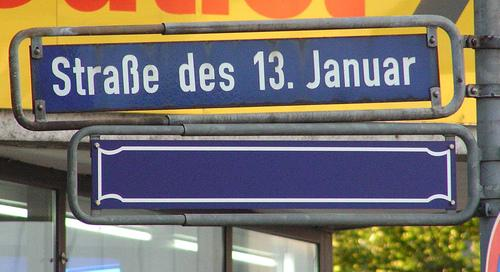How would you summarize the sign's appearance? It is a blue signpost with white German text, a metal frame, and a pole. What are the main colors depicted in the image and their respective objects? Yellow for the upper street sign, blue for the lower street sign, and white for the text. What is the overall theme of the image? A street sign with German writing, indicating a location or direction. Share a concise description of the primary subject in the image. German text on a blue street sign with a yellow street sign above it. What is the most notable characteristic of the image? The combination of a blue and a yellow street sign, both featuring German text. Mention the main features of the sign in the image. The signs are rectangular, the upper one is yellow with black lettering in German, and the lower one is blue with white lettering in German. Both have a metal frame and are mounted on a pole. Describe the position and appearance of the sign within the image. The blue sign is in the foreground with white German letters, positioned below a yellow sign with black German letters. Briefly describe the appearance of the background in the image. The background is relatively plain, focusing on the two street signs. What is the primary color of the sign and what is written on it? The primary color of the lower sign is blue with white text in German. Provide a brief description of the most prominent object in the image. A blue street sign written in German, positioned below a yellow street sign, both mounted on a pole. 